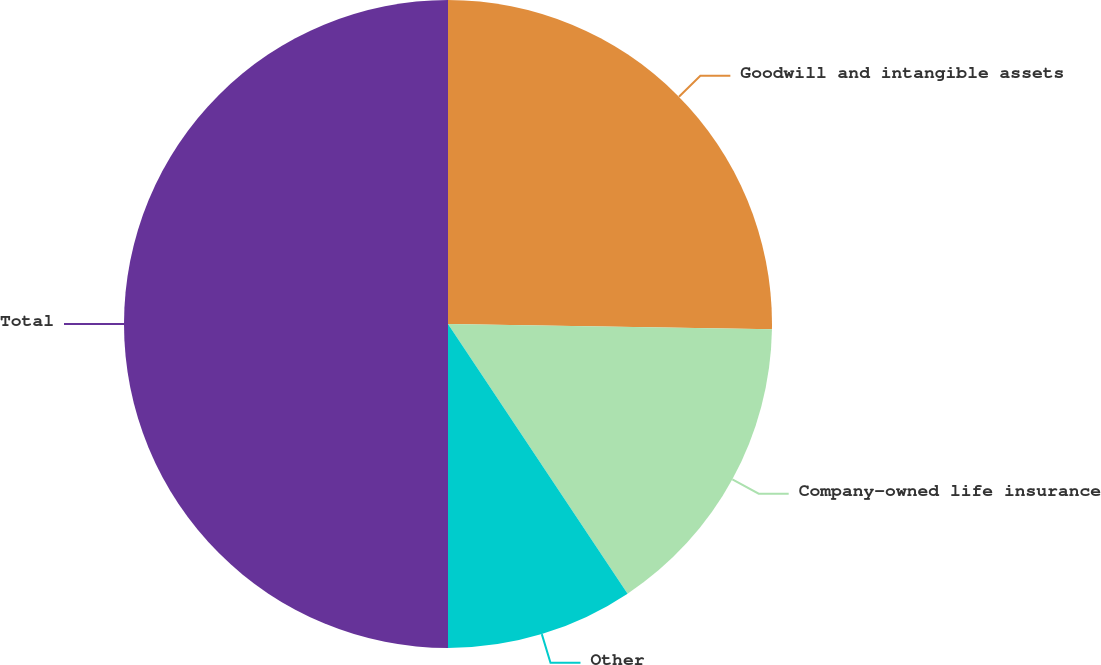<chart> <loc_0><loc_0><loc_500><loc_500><pie_chart><fcel>Goodwill and intangible assets<fcel>Company-owned life insurance<fcel>Other<fcel>Total<nl><fcel>25.26%<fcel>15.39%<fcel>9.35%<fcel>50.0%<nl></chart> 